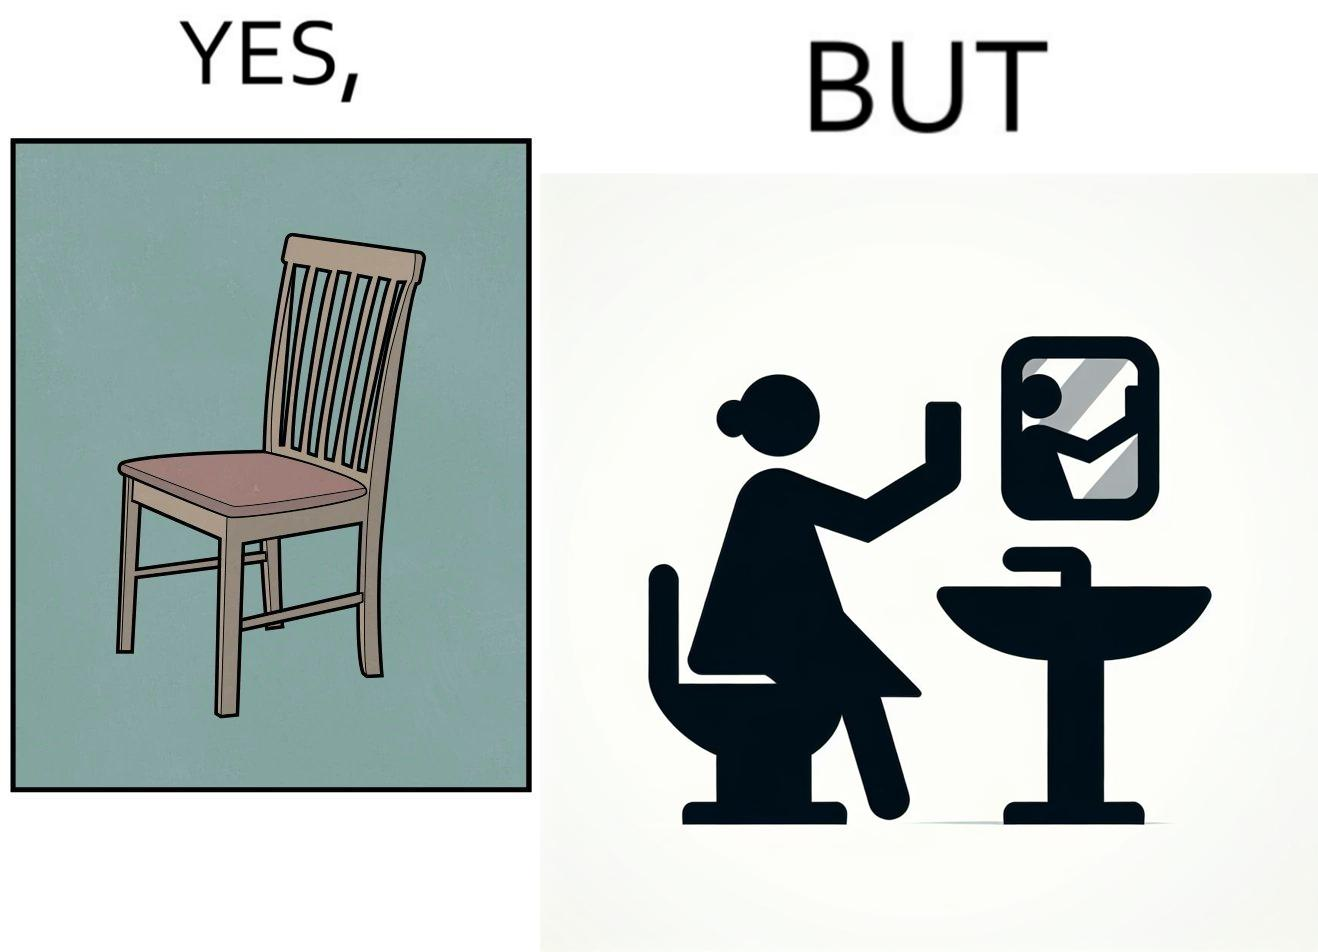Describe the contrast between the left and right parts of this image. In the left part of the image: a chair. In the right part of the image: a woman sitting by the sink taking a selfie using a mirror. 